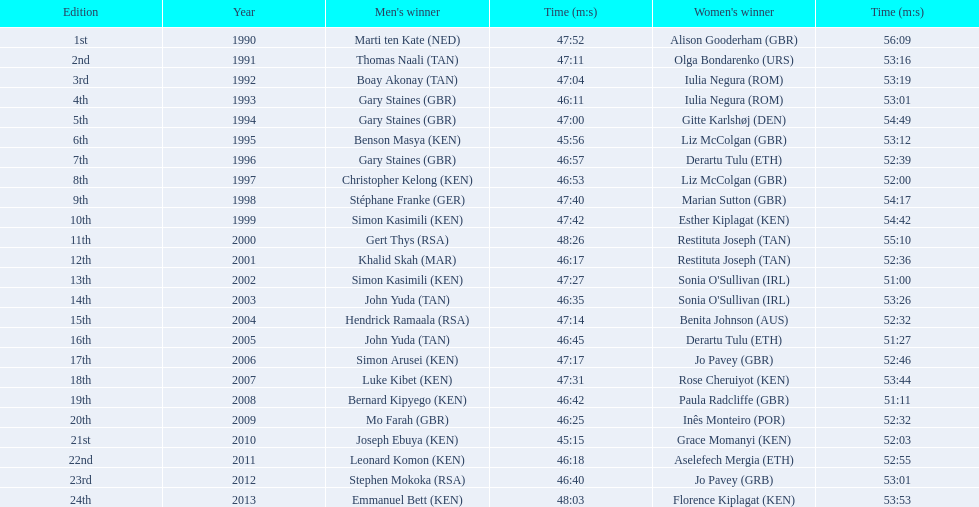What are the appellations of every male victor? Marti ten Kate (NED), Thomas Naali (TAN), Boay Akonay (TAN), Gary Staines (GBR), Gary Staines (GBR), Benson Masya (KEN), Gary Staines (GBR), Christopher Kelong (KEN), Stéphane Franke (GER), Simon Kasimili (KEN), Gert Thys (RSA), Khalid Skah (MAR), Simon Kasimili (KEN), John Yuda (TAN), Hendrick Ramaala (RSA), John Yuda (TAN), Simon Arusei (KEN), Luke Kibet (KEN), Bernard Kipyego (KEN), Mo Farah (GBR), Joseph Ebuya (KEN), Leonard Komon (KEN), Stephen Mokoka (RSA), Emmanuel Bett (KEN). When did they compete? 1990, 1991, 1992, 1993, 1994, 1995, 1996, 1997, 1998, 1999, 2000, 2001, 2002, 2003, 2004, 2005, 2006, 2007, 2008, 2009, 2010, 2011, 2012, 2013. And what were their durations? 47:52, 47:11, 47:04, 46:11, 47:00, 45:56, 46:57, 46:53, 47:40, 47:42, 48:26, 46:17, 47:27, 46:35, 47:14, 46:45, 47:17, 47:31, 46:42, 46:25, 45:15, 46:18, 46:40, 48:03. Among those durations, which sportsman had the quickest time? Joseph Ebuya (KEN). 